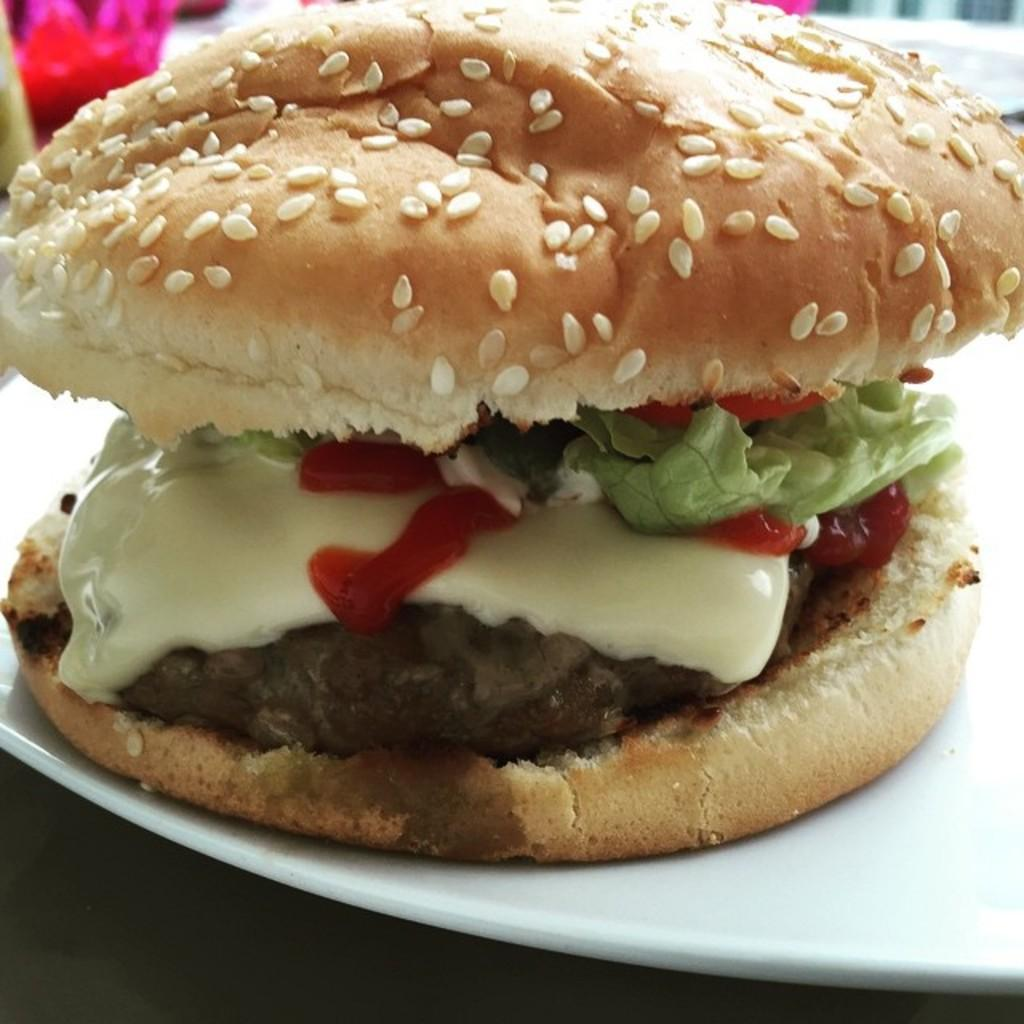What type of food is the main subject of the image? There is a burger in the image. What is on top of the burger? The burger has eatables on it. On what is the burger placed? The burger is on a white plate. What type of cloud can be seen in the image? There is no cloud present in the image; it features a burger on a white plate. What is the burger's desire in the image? The burger is an inanimate object and does not have desires. 